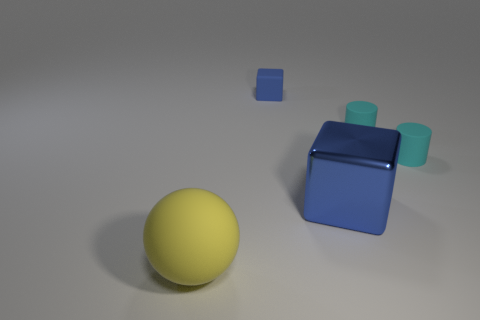How many cyan cylinders must be subtracted to get 1 cyan cylinders? 1 Add 2 matte objects. How many objects exist? 7 Subtract all cubes. How many objects are left? 3 Add 5 spheres. How many spheres are left? 6 Add 4 large red matte balls. How many large red matte balls exist? 4 Subtract 0 red spheres. How many objects are left? 5 Subtract all large yellow things. Subtract all shiny blocks. How many objects are left? 3 